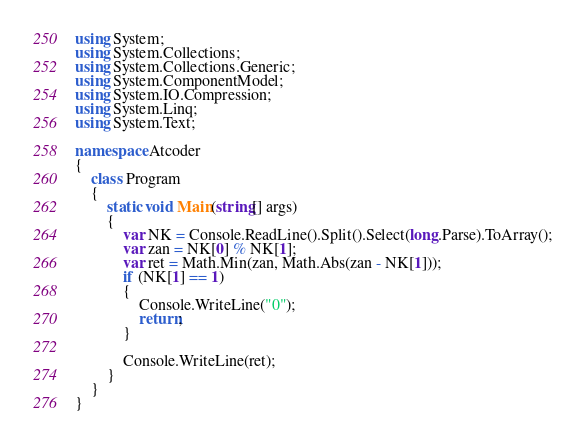Convert code to text. <code><loc_0><loc_0><loc_500><loc_500><_C#_>using System;
using System.Collections;
using System.Collections.Generic;
using System.ComponentModel;
using System.IO.Compression;
using System.Linq;
using System.Text;

namespace Atcoder
{
    class Program
    {
        static void Main(string[] args)
        {
            var NK = Console.ReadLine().Split().Select(long.Parse).ToArray();
            var zan = NK[0] % NK[1];
            var ret = Math.Min(zan, Math.Abs(zan - NK[1]));
            if (NK[1] == 1)
            {
                Console.WriteLine("0");
                return;
            }
            
            Console.WriteLine(ret);
        }
    }
}</code> 